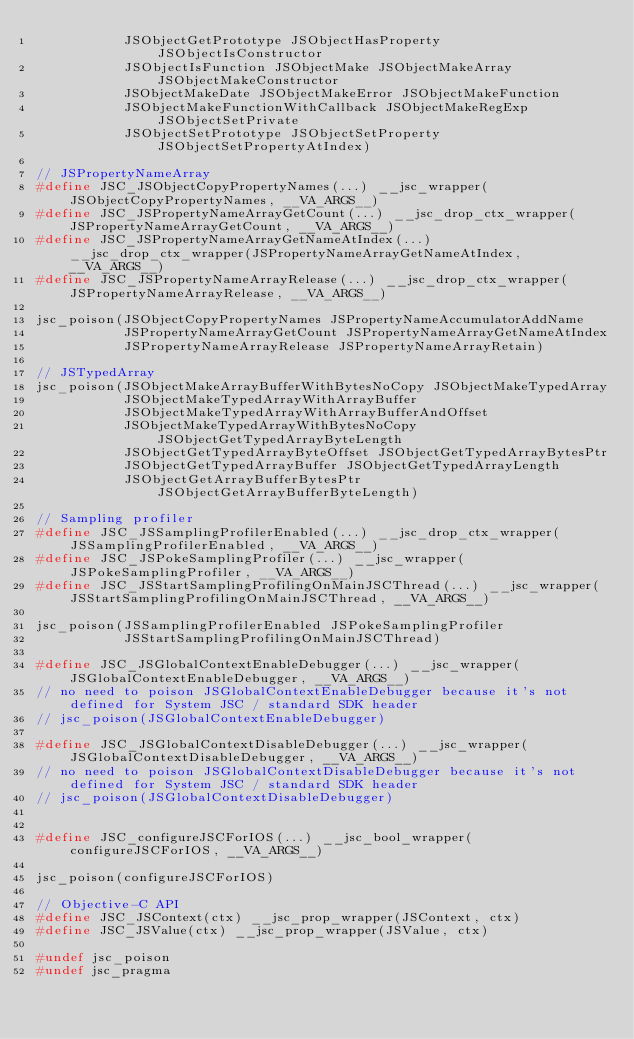Convert code to text. <code><loc_0><loc_0><loc_500><loc_500><_C_>           JSObjectGetPrototype JSObjectHasProperty JSObjectIsConstructor
           JSObjectIsFunction JSObjectMake JSObjectMakeArray JSObjectMakeConstructor
           JSObjectMakeDate JSObjectMakeError JSObjectMakeFunction
           JSObjectMakeFunctionWithCallback JSObjectMakeRegExp JSObjectSetPrivate
           JSObjectSetPrototype JSObjectSetProperty JSObjectSetPropertyAtIndex)

// JSPropertyNameArray
#define JSC_JSObjectCopyPropertyNames(...) __jsc_wrapper(JSObjectCopyPropertyNames, __VA_ARGS__)
#define JSC_JSPropertyNameArrayGetCount(...) __jsc_drop_ctx_wrapper(JSPropertyNameArrayGetCount, __VA_ARGS__)
#define JSC_JSPropertyNameArrayGetNameAtIndex(...) __jsc_drop_ctx_wrapper(JSPropertyNameArrayGetNameAtIndex, __VA_ARGS__)
#define JSC_JSPropertyNameArrayRelease(...) __jsc_drop_ctx_wrapper(JSPropertyNameArrayRelease, __VA_ARGS__)

jsc_poison(JSObjectCopyPropertyNames JSPropertyNameAccumulatorAddName
           JSPropertyNameArrayGetCount JSPropertyNameArrayGetNameAtIndex
           JSPropertyNameArrayRelease JSPropertyNameArrayRetain)

// JSTypedArray
jsc_poison(JSObjectMakeArrayBufferWithBytesNoCopy JSObjectMakeTypedArray
           JSObjectMakeTypedArrayWithArrayBuffer
           JSObjectMakeTypedArrayWithArrayBufferAndOffset
           JSObjectMakeTypedArrayWithBytesNoCopy JSObjectGetTypedArrayByteLength
           JSObjectGetTypedArrayByteOffset JSObjectGetTypedArrayBytesPtr
           JSObjectGetTypedArrayBuffer JSObjectGetTypedArrayLength
           JSObjectGetArrayBufferBytesPtr JSObjectGetArrayBufferByteLength)

// Sampling profiler
#define JSC_JSSamplingProfilerEnabled(...) __jsc_drop_ctx_wrapper(JSSamplingProfilerEnabled, __VA_ARGS__)
#define JSC_JSPokeSamplingProfiler(...) __jsc_wrapper(JSPokeSamplingProfiler, __VA_ARGS__)
#define JSC_JSStartSamplingProfilingOnMainJSCThread(...) __jsc_wrapper(JSStartSamplingProfilingOnMainJSCThread, __VA_ARGS__)

jsc_poison(JSSamplingProfilerEnabled JSPokeSamplingProfiler
           JSStartSamplingProfilingOnMainJSCThread)

#define JSC_JSGlobalContextEnableDebugger(...) __jsc_wrapper(JSGlobalContextEnableDebugger, __VA_ARGS__)
// no need to poison JSGlobalContextEnableDebugger because it's not defined for System JSC / standard SDK header
// jsc_poison(JSGlobalContextEnableDebugger)

#define JSC_JSGlobalContextDisableDebugger(...) __jsc_wrapper(JSGlobalContextDisableDebugger, __VA_ARGS__)
// no need to poison JSGlobalContextDisableDebugger because it's not defined for System JSC / standard SDK header
// jsc_poison(JSGlobalContextDisableDebugger)


#define JSC_configureJSCForIOS(...) __jsc_bool_wrapper(configureJSCForIOS, __VA_ARGS__)

jsc_poison(configureJSCForIOS)

// Objective-C API
#define JSC_JSContext(ctx) __jsc_prop_wrapper(JSContext, ctx)
#define JSC_JSValue(ctx) __jsc_prop_wrapper(JSValue, ctx)

#undef jsc_poison
#undef jsc_pragma
</code> 